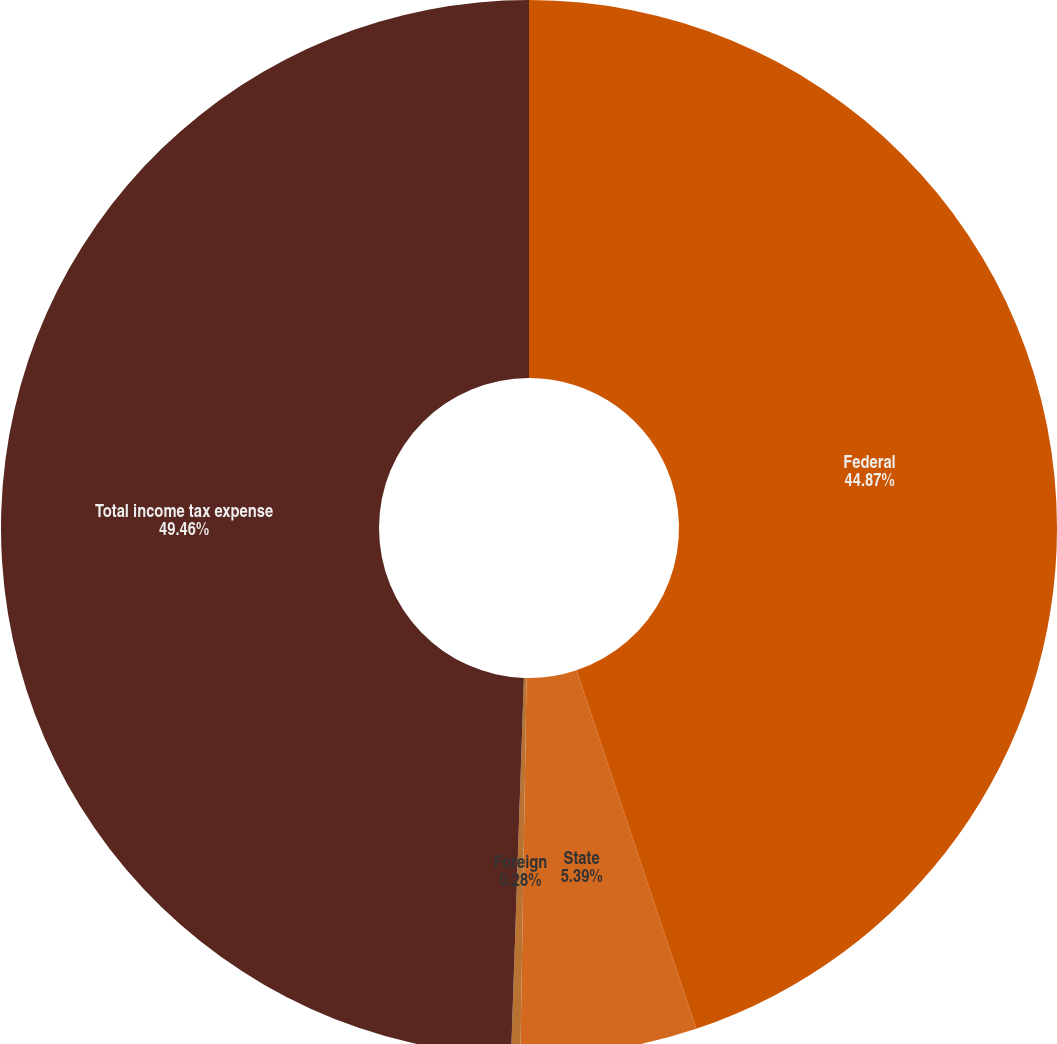<chart> <loc_0><loc_0><loc_500><loc_500><pie_chart><fcel>Federal<fcel>State<fcel>Foreign<fcel>Total income tax expense<nl><fcel>44.87%<fcel>5.39%<fcel>0.28%<fcel>49.46%<nl></chart> 